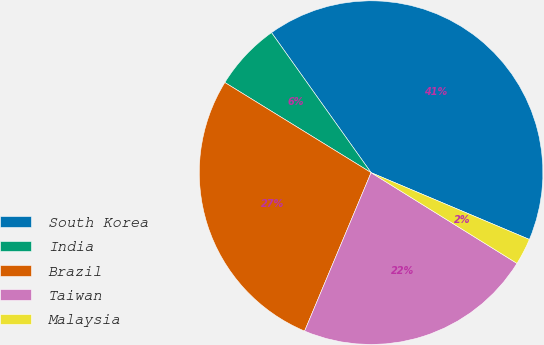Convert chart to OTSL. <chart><loc_0><loc_0><loc_500><loc_500><pie_chart><fcel>South Korea<fcel>India<fcel>Brazil<fcel>Taiwan<fcel>Malaysia<nl><fcel>41.2%<fcel>6.37%<fcel>27.47%<fcel>22.47%<fcel>2.5%<nl></chart> 